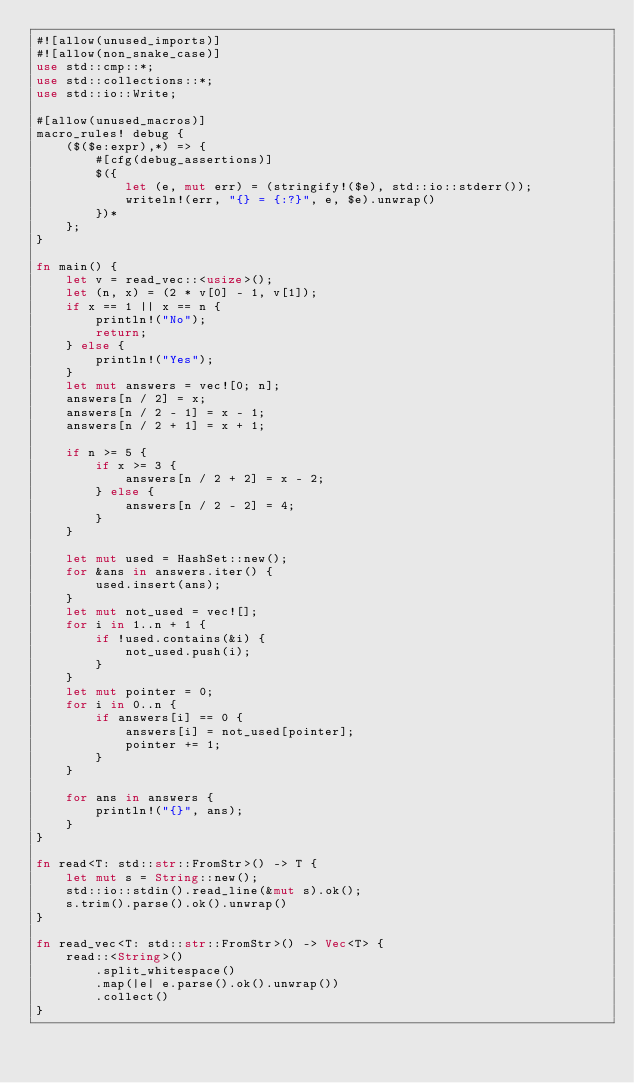<code> <loc_0><loc_0><loc_500><loc_500><_Rust_>#![allow(unused_imports)]
#![allow(non_snake_case)]
use std::cmp::*;
use std::collections::*;
use std::io::Write;

#[allow(unused_macros)]
macro_rules! debug {
    ($($e:expr),*) => {
        #[cfg(debug_assertions)]
        $({
            let (e, mut err) = (stringify!($e), std::io::stderr());
            writeln!(err, "{} = {:?}", e, $e).unwrap()
        })*
    };
}

fn main() {
    let v = read_vec::<usize>();
    let (n, x) = (2 * v[0] - 1, v[1]);
    if x == 1 || x == n {
        println!("No");
        return;
    } else {
        println!("Yes");
    }
    let mut answers = vec![0; n];
    answers[n / 2] = x;
    answers[n / 2 - 1] = x - 1;
    answers[n / 2 + 1] = x + 1;

    if n >= 5 {
        if x >= 3 {
            answers[n / 2 + 2] = x - 2;
        } else {
            answers[n / 2 - 2] = 4;
        }
    }

    let mut used = HashSet::new();
    for &ans in answers.iter() {
        used.insert(ans);
    }
    let mut not_used = vec![];
    for i in 1..n + 1 {
        if !used.contains(&i) {
            not_used.push(i);
        }
    }
    let mut pointer = 0;
    for i in 0..n {
        if answers[i] == 0 {
            answers[i] = not_used[pointer];
            pointer += 1;
        }
    }

    for ans in answers {
        println!("{}", ans);
    }
}

fn read<T: std::str::FromStr>() -> T {
    let mut s = String::new();
    std::io::stdin().read_line(&mut s).ok();
    s.trim().parse().ok().unwrap()
}

fn read_vec<T: std::str::FromStr>() -> Vec<T> {
    read::<String>()
        .split_whitespace()
        .map(|e| e.parse().ok().unwrap())
        .collect()
}
</code> 